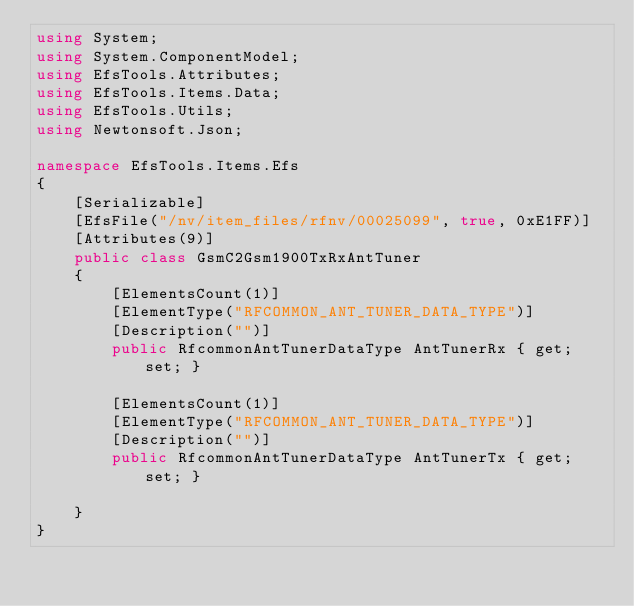Convert code to text. <code><loc_0><loc_0><loc_500><loc_500><_C#_>using System;
using System.ComponentModel;
using EfsTools.Attributes;
using EfsTools.Items.Data;
using EfsTools.Utils;
using Newtonsoft.Json;

namespace EfsTools.Items.Efs
{
    [Serializable]
    [EfsFile("/nv/item_files/rfnv/00025099", true, 0xE1FF)]
    [Attributes(9)]
    public class GsmC2Gsm1900TxRxAntTuner
    {
        [ElementsCount(1)]
        [ElementType("RFCOMMON_ANT_TUNER_DATA_TYPE")]
        [Description("")]
        public RfcommonAntTunerDataType AntTunerRx { get; set; }
        
        [ElementsCount(1)]
        [ElementType("RFCOMMON_ANT_TUNER_DATA_TYPE")]
        [Description("")]
        public RfcommonAntTunerDataType AntTunerTx { get; set; }
        
    }
}
</code> 